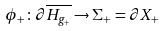<formula> <loc_0><loc_0><loc_500><loc_500>\phi _ { + } \colon \partial \overline { H _ { g _ { + } } } \rightarrow \Sigma _ { + } = \partial X _ { + }</formula> 